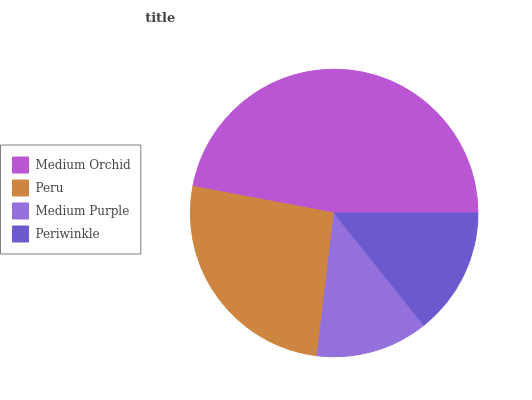Is Medium Purple the minimum?
Answer yes or no. Yes. Is Medium Orchid the maximum?
Answer yes or no. Yes. Is Peru the minimum?
Answer yes or no. No. Is Peru the maximum?
Answer yes or no. No. Is Medium Orchid greater than Peru?
Answer yes or no. Yes. Is Peru less than Medium Orchid?
Answer yes or no. Yes. Is Peru greater than Medium Orchid?
Answer yes or no. No. Is Medium Orchid less than Peru?
Answer yes or no. No. Is Peru the high median?
Answer yes or no. Yes. Is Periwinkle the low median?
Answer yes or no. Yes. Is Periwinkle the high median?
Answer yes or no. No. Is Peru the low median?
Answer yes or no. No. 